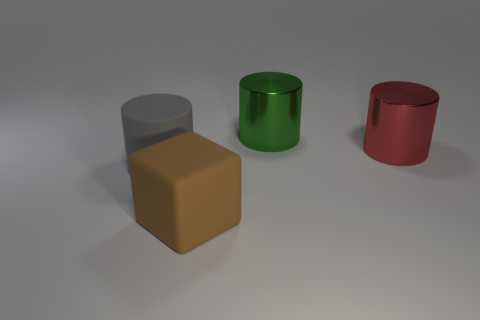Is the color of the large matte cylinder the same as the big cube?
Offer a terse response. No. Are there any big green cylinders behind the shiny thing behind the metal cylinder that is on the right side of the green object?
Your answer should be compact. No. What number of brown things have the same size as the red shiny thing?
Provide a short and direct response. 1. Do the rubber cube in front of the red object and the metallic cylinder in front of the big green metal cylinder have the same size?
Provide a short and direct response. Yes. There is a thing that is both behind the big block and left of the green object; what shape is it?
Give a very brief answer. Cylinder. Is there another cylinder of the same color as the large matte cylinder?
Your answer should be compact. No. Are there any small yellow metal objects?
Offer a terse response. No. What is the color of the large rubber object that is left of the large block?
Provide a short and direct response. Gray. Is the size of the brown rubber cube the same as the metallic thing that is behind the red metallic cylinder?
Ensure brevity in your answer.  Yes. There is a thing that is behind the large brown rubber thing and to the left of the big green object; what size is it?
Give a very brief answer. Large. 